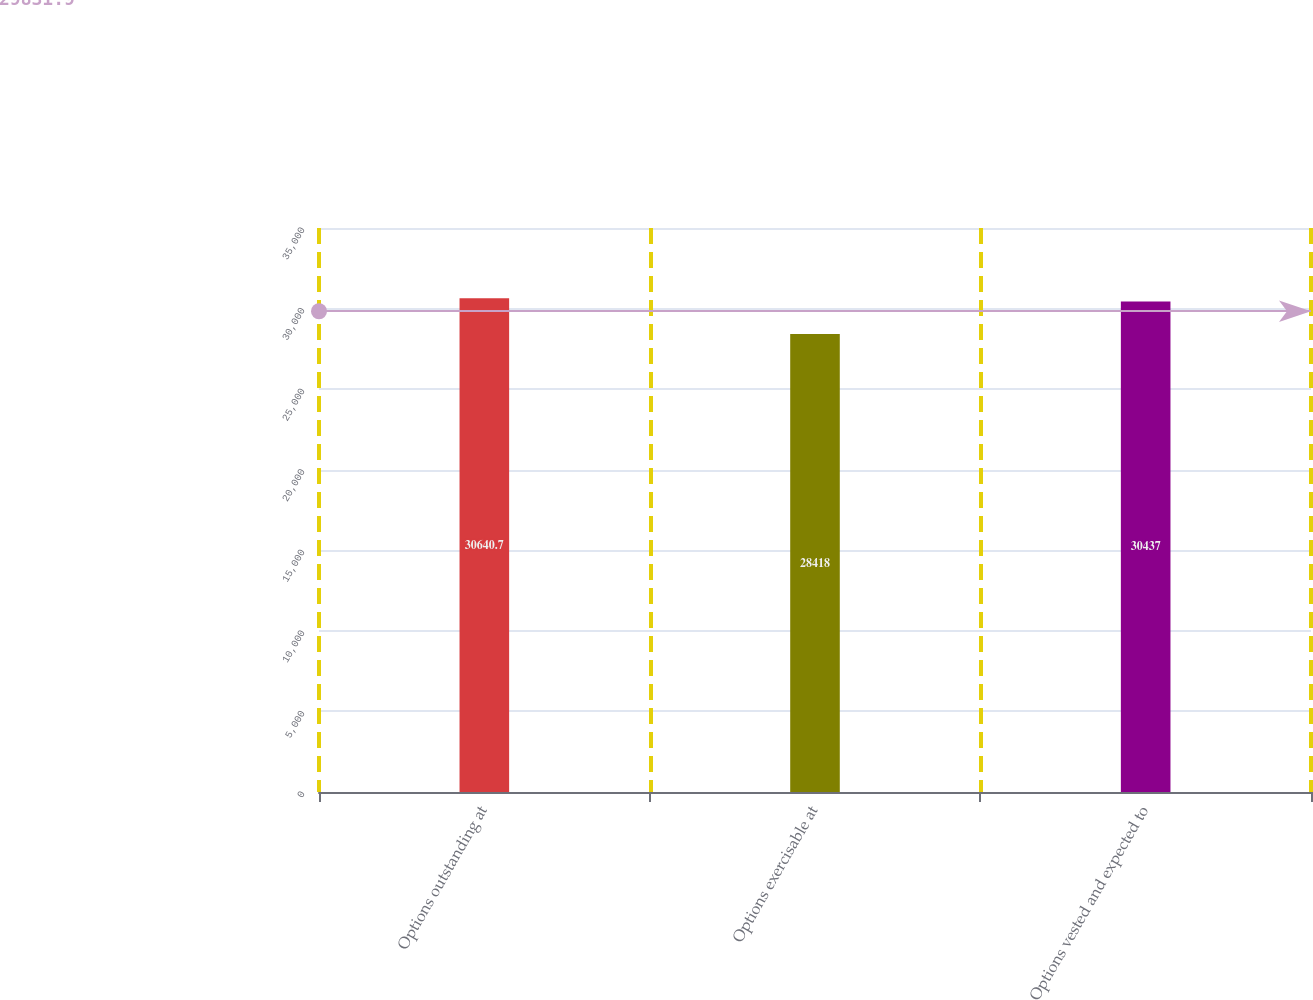Convert chart to OTSL. <chart><loc_0><loc_0><loc_500><loc_500><bar_chart><fcel>Options outstanding at<fcel>Options exercisable at<fcel>Options vested and expected to<nl><fcel>30640.7<fcel>28418<fcel>30437<nl></chart> 